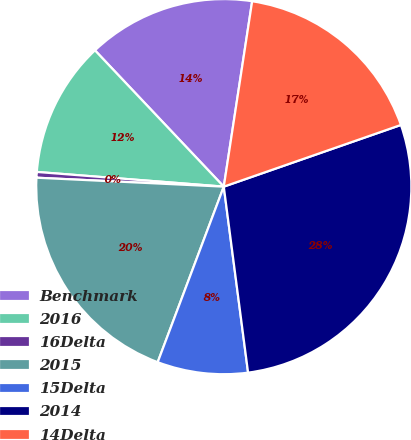Convert chart to OTSL. <chart><loc_0><loc_0><loc_500><loc_500><pie_chart><fcel>Benchmark<fcel>2016<fcel>16Delta<fcel>2015<fcel>15Delta<fcel>2014<fcel>14Delta<nl><fcel>14.47%<fcel>11.7%<fcel>0.49%<fcel>20.03%<fcel>7.8%<fcel>28.27%<fcel>17.25%<nl></chart> 